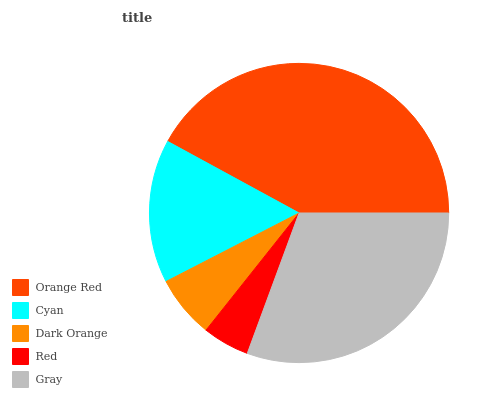Is Red the minimum?
Answer yes or no. Yes. Is Orange Red the maximum?
Answer yes or no. Yes. Is Cyan the minimum?
Answer yes or no. No. Is Cyan the maximum?
Answer yes or no. No. Is Orange Red greater than Cyan?
Answer yes or no. Yes. Is Cyan less than Orange Red?
Answer yes or no. Yes. Is Cyan greater than Orange Red?
Answer yes or no. No. Is Orange Red less than Cyan?
Answer yes or no. No. Is Cyan the high median?
Answer yes or no. Yes. Is Cyan the low median?
Answer yes or no. Yes. Is Dark Orange the high median?
Answer yes or no. No. Is Orange Red the low median?
Answer yes or no. No. 